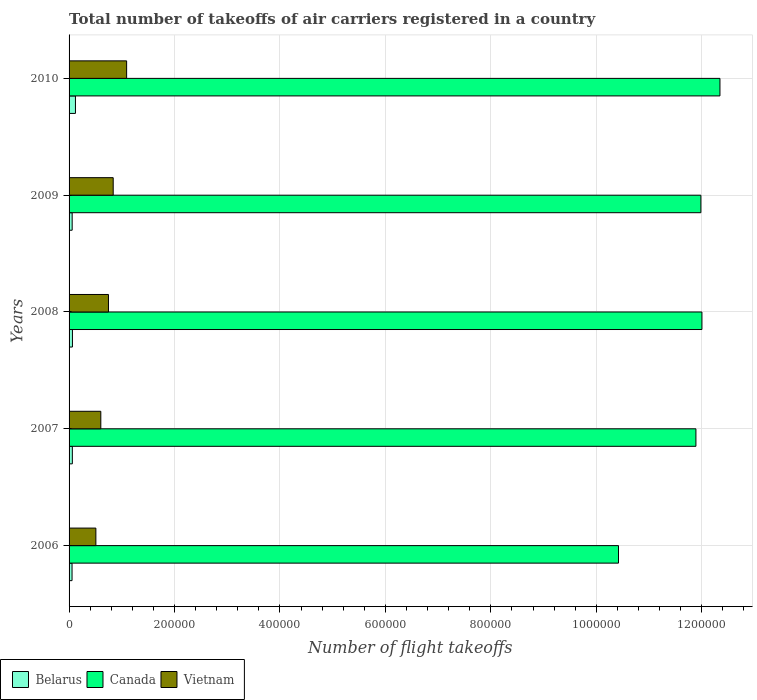How many different coloured bars are there?
Your response must be concise. 3. How many groups of bars are there?
Your answer should be very brief. 5. Are the number of bars per tick equal to the number of legend labels?
Keep it short and to the point. Yes. How many bars are there on the 1st tick from the top?
Your answer should be very brief. 3. What is the label of the 3rd group of bars from the top?
Offer a terse response. 2008. What is the total number of flight takeoffs in Canada in 2006?
Offer a terse response. 1.04e+06. Across all years, what is the maximum total number of flight takeoffs in Vietnam?
Provide a succinct answer. 1.09e+05. Across all years, what is the minimum total number of flight takeoffs in Belarus?
Give a very brief answer. 5646. In which year was the total number of flight takeoffs in Canada maximum?
Provide a short and direct response. 2010. In which year was the total number of flight takeoffs in Belarus minimum?
Give a very brief answer. 2006. What is the total total number of flight takeoffs in Belarus in the graph?
Provide a succinct answer. 3.62e+04. What is the difference between the total number of flight takeoffs in Belarus in 2007 and that in 2010?
Offer a very short reply. -5891. What is the difference between the total number of flight takeoffs in Vietnam in 2010 and the total number of flight takeoffs in Belarus in 2008?
Keep it short and to the point. 1.03e+05. What is the average total number of flight takeoffs in Canada per year?
Provide a succinct answer. 1.17e+06. In the year 2009, what is the difference between the total number of flight takeoffs in Vietnam and total number of flight takeoffs in Belarus?
Provide a succinct answer. 7.79e+04. What is the ratio of the total number of flight takeoffs in Vietnam in 2007 to that in 2008?
Your answer should be compact. 0.81. Is the total number of flight takeoffs in Belarus in 2007 less than that in 2010?
Offer a very short reply. Yes. Is the difference between the total number of flight takeoffs in Vietnam in 2007 and 2008 greater than the difference between the total number of flight takeoffs in Belarus in 2007 and 2008?
Make the answer very short. No. What is the difference between the highest and the second highest total number of flight takeoffs in Canada?
Your answer should be compact. 3.42e+04. What is the difference between the highest and the lowest total number of flight takeoffs in Belarus?
Your response must be concise. 6455. Is the sum of the total number of flight takeoffs in Belarus in 2006 and 2007 greater than the maximum total number of flight takeoffs in Vietnam across all years?
Offer a very short reply. No. What does the 1st bar from the top in 2010 represents?
Your response must be concise. Vietnam. What does the 1st bar from the bottom in 2009 represents?
Offer a terse response. Belarus. Is it the case that in every year, the sum of the total number of flight takeoffs in Belarus and total number of flight takeoffs in Vietnam is greater than the total number of flight takeoffs in Canada?
Give a very brief answer. No. How many years are there in the graph?
Ensure brevity in your answer.  5. Where does the legend appear in the graph?
Give a very brief answer. Bottom left. How are the legend labels stacked?
Give a very brief answer. Horizontal. What is the title of the graph?
Offer a terse response. Total number of takeoffs of air carriers registered in a country. Does "Sint Maarten (Dutch part)" appear as one of the legend labels in the graph?
Ensure brevity in your answer.  No. What is the label or title of the X-axis?
Offer a terse response. Number of flight takeoffs. What is the Number of flight takeoffs of Belarus in 2006?
Keep it short and to the point. 5646. What is the Number of flight takeoffs of Canada in 2006?
Ensure brevity in your answer.  1.04e+06. What is the Number of flight takeoffs of Vietnam in 2006?
Offer a terse response. 5.08e+04. What is the Number of flight takeoffs of Belarus in 2007?
Provide a succinct answer. 6210. What is the Number of flight takeoffs of Canada in 2007?
Give a very brief answer. 1.19e+06. What is the Number of flight takeoffs in Vietnam in 2007?
Offer a very short reply. 6.02e+04. What is the Number of flight takeoffs of Belarus in 2008?
Offer a very short reply. 6371. What is the Number of flight takeoffs of Canada in 2008?
Offer a very short reply. 1.20e+06. What is the Number of flight takeoffs of Vietnam in 2008?
Offer a terse response. 7.47e+04. What is the Number of flight takeoffs in Belarus in 2009?
Keep it short and to the point. 5868. What is the Number of flight takeoffs in Canada in 2009?
Make the answer very short. 1.20e+06. What is the Number of flight takeoffs in Vietnam in 2009?
Keep it short and to the point. 8.37e+04. What is the Number of flight takeoffs in Belarus in 2010?
Ensure brevity in your answer.  1.21e+04. What is the Number of flight takeoffs in Canada in 2010?
Your answer should be compact. 1.23e+06. What is the Number of flight takeoffs of Vietnam in 2010?
Provide a succinct answer. 1.09e+05. Across all years, what is the maximum Number of flight takeoffs of Belarus?
Your answer should be very brief. 1.21e+04. Across all years, what is the maximum Number of flight takeoffs of Canada?
Your response must be concise. 1.23e+06. Across all years, what is the maximum Number of flight takeoffs of Vietnam?
Your answer should be very brief. 1.09e+05. Across all years, what is the minimum Number of flight takeoffs of Belarus?
Your response must be concise. 5646. Across all years, what is the minimum Number of flight takeoffs in Canada?
Keep it short and to the point. 1.04e+06. Across all years, what is the minimum Number of flight takeoffs in Vietnam?
Your answer should be compact. 5.08e+04. What is the total Number of flight takeoffs of Belarus in the graph?
Keep it short and to the point. 3.62e+04. What is the total Number of flight takeoffs of Canada in the graph?
Provide a short and direct response. 5.86e+06. What is the total Number of flight takeoffs in Vietnam in the graph?
Provide a short and direct response. 3.79e+05. What is the difference between the Number of flight takeoffs of Belarus in 2006 and that in 2007?
Your answer should be compact. -564. What is the difference between the Number of flight takeoffs in Canada in 2006 and that in 2007?
Your answer should be compact. -1.47e+05. What is the difference between the Number of flight takeoffs in Vietnam in 2006 and that in 2007?
Make the answer very short. -9378. What is the difference between the Number of flight takeoffs in Belarus in 2006 and that in 2008?
Offer a very short reply. -725. What is the difference between the Number of flight takeoffs of Canada in 2006 and that in 2008?
Provide a succinct answer. -1.58e+05. What is the difference between the Number of flight takeoffs of Vietnam in 2006 and that in 2008?
Ensure brevity in your answer.  -2.39e+04. What is the difference between the Number of flight takeoffs in Belarus in 2006 and that in 2009?
Provide a short and direct response. -222. What is the difference between the Number of flight takeoffs in Canada in 2006 and that in 2009?
Your answer should be very brief. -1.56e+05. What is the difference between the Number of flight takeoffs in Vietnam in 2006 and that in 2009?
Your response must be concise. -3.29e+04. What is the difference between the Number of flight takeoffs in Belarus in 2006 and that in 2010?
Offer a very short reply. -6455. What is the difference between the Number of flight takeoffs in Canada in 2006 and that in 2010?
Your answer should be compact. -1.92e+05. What is the difference between the Number of flight takeoffs in Vietnam in 2006 and that in 2010?
Provide a short and direct response. -5.83e+04. What is the difference between the Number of flight takeoffs in Belarus in 2007 and that in 2008?
Provide a short and direct response. -161. What is the difference between the Number of flight takeoffs of Canada in 2007 and that in 2008?
Provide a succinct answer. -1.14e+04. What is the difference between the Number of flight takeoffs of Vietnam in 2007 and that in 2008?
Provide a short and direct response. -1.45e+04. What is the difference between the Number of flight takeoffs in Belarus in 2007 and that in 2009?
Offer a very short reply. 342. What is the difference between the Number of flight takeoffs in Canada in 2007 and that in 2009?
Your answer should be very brief. -9434. What is the difference between the Number of flight takeoffs in Vietnam in 2007 and that in 2009?
Make the answer very short. -2.35e+04. What is the difference between the Number of flight takeoffs in Belarus in 2007 and that in 2010?
Ensure brevity in your answer.  -5891. What is the difference between the Number of flight takeoffs of Canada in 2007 and that in 2010?
Give a very brief answer. -4.56e+04. What is the difference between the Number of flight takeoffs in Vietnam in 2007 and that in 2010?
Offer a terse response. -4.90e+04. What is the difference between the Number of flight takeoffs in Belarus in 2008 and that in 2009?
Provide a short and direct response. 503. What is the difference between the Number of flight takeoffs in Canada in 2008 and that in 2009?
Your answer should be compact. 1980. What is the difference between the Number of flight takeoffs of Vietnam in 2008 and that in 2009?
Make the answer very short. -8981. What is the difference between the Number of flight takeoffs in Belarus in 2008 and that in 2010?
Your answer should be compact. -5730. What is the difference between the Number of flight takeoffs in Canada in 2008 and that in 2010?
Give a very brief answer. -3.42e+04. What is the difference between the Number of flight takeoffs in Vietnam in 2008 and that in 2010?
Give a very brief answer. -3.44e+04. What is the difference between the Number of flight takeoffs in Belarus in 2009 and that in 2010?
Keep it short and to the point. -6233. What is the difference between the Number of flight takeoffs in Canada in 2009 and that in 2010?
Ensure brevity in your answer.  -3.61e+04. What is the difference between the Number of flight takeoffs of Vietnam in 2009 and that in 2010?
Provide a succinct answer. -2.55e+04. What is the difference between the Number of flight takeoffs of Belarus in 2006 and the Number of flight takeoffs of Canada in 2007?
Keep it short and to the point. -1.18e+06. What is the difference between the Number of flight takeoffs in Belarus in 2006 and the Number of flight takeoffs in Vietnam in 2007?
Provide a short and direct response. -5.46e+04. What is the difference between the Number of flight takeoffs in Canada in 2006 and the Number of flight takeoffs in Vietnam in 2007?
Ensure brevity in your answer.  9.82e+05. What is the difference between the Number of flight takeoffs in Belarus in 2006 and the Number of flight takeoffs in Canada in 2008?
Offer a very short reply. -1.19e+06. What is the difference between the Number of flight takeoffs of Belarus in 2006 and the Number of flight takeoffs of Vietnam in 2008?
Provide a short and direct response. -6.91e+04. What is the difference between the Number of flight takeoffs of Canada in 2006 and the Number of flight takeoffs of Vietnam in 2008?
Provide a short and direct response. 9.67e+05. What is the difference between the Number of flight takeoffs in Belarus in 2006 and the Number of flight takeoffs in Canada in 2009?
Make the answer very short. -1.19e+06. What is the difference between the Number of flight takeoffs of Belarus in 2006 and the Number of flight takeoffs of Vietnam in 2009?
Offer a terse response. -7.81e+04. What is the difference between the Number of flight takeoffs in Canada in 2006 and the Number of flight takeoffs in Vietnam in 2009?
Make the answer very short. 9.58e+05. What is the difference between the Number of flight takeoffs of Belarus in 2006 and the Number of flight takeoffs of Canada in 2010?
Your response must be concise. -1.23e+06. What is the difference between the Number of flight takeoffs of Belarus in 2006 and the Number of flight takeoffs of Vietnam in 2010?
Your response must be concise. -1.04e+05. What is the difference between the Number of flight takeoffs of Canada in 2006 and the Number of flight takeoffs of Vietnam in 2010?
Your answer should be compact. 9.33e+05. What is the difference between the Number of flight takeoffs in Belarus in 2007 and the Number of flight takeoffs in Canada in 2008?
Provide a succinct answer. -1.19e+06. What is the difference between the Number of flight takeoffs of Belarus in 2007 and the Number of flight takeoffs of Vietnam in 2008?
Ensure brevity in your answer.  -6.85e+04. What is the difference between the Number of flight takeoffs in Canada in 2007 and the Number of flight takeoffs in Vietnam in 2008?
Keep it short and to the point. 1.11e+06. What is the difference between the Number of flight takeoffs of Belarus in 2007 and the Number of flight takeoffs of Canada in 2009?
Your answer should be very brief. -1.19e+06. What is the difference between the Number of flight takeoffs of Belarus in 2007 and the Number of flight takeoffs of Vietnam in 2009?
Your response must be concise. -7.75e+04. What is the difference between the Number of flight takeoffs in Canada in 2007 and the Number of flight takeoffs in Vietnam in 2009?
Provide a succinct answer. 1.11e+06. What is the difference between the Number of flight takeoffs in Belarus in 2007 and the Number of flight takeoffs in Canada in 2010?
Provide a short and direct response. -1.23e+06. What is the difference between the Number of flight takeoffs in Belarus in 2007 and the Number of flight takeoffs in Vietnam in 2010?
Offer a terse response. -1.03e+05. What is the difference between the Number of flight takeoffs in Canada in 2007 and the Number of flight takeoffs in Vietnam in 2010?
Offer a terse response. 1.08e+06. What is the difference between the Number of flight takeoffs in Belarus in 2008 and the Number of flight takeoffs in Canada in 2009?
Provide a succinct answer. -1.19e+06. What is the difference between the Number of flight takeoffs of Belarus in 2008 and the Number of flight takeoffs of Vietnam in 2009?
Provide a succinct answer. -7.73e+04. What is the difference between the Number of flight takeoffs in Canada in 2008 and the Number of flight takeoffs in Vietnam in 2009?
Your answer should be compact. 1.12e+06. What is the difference between the Number of flight takeoffs in Belarus in 2008 and the Number of flight takeoffs in Canada in 2010?
Offer a terse response. -1.23e+06. What is the difference between the Number of flight takeoffs in Belarus in 2008 and the Number of flight takeoffs in Vietnam in 2010?
Give a very brief answer. -1.03e+05. What is the difference between the Number of flight takeoffs in Canada in 2008 and the Number of flight takeoffs in Vietnam in 2010?
Offer a terse response. 1.09e+06. What is the difference between the Number of flight takeoffs in Belarus in 2009 and the Number of flight takeoffs in Canada in 2010?
Offer a terse response. -1.23e+06. What is the difference between the Number of flight takeoffs of Belarus in 2009 and the Number of flight takeoffs of Vietnam in 2010?
Provide a short and direct response. -1.03e+05. What is the difference between the Number of flight takeoffs in Canada in 2009 and the Number of flight takeoffs in Vietnam in 2010?
Provide a succinct answer. 1.09e+06. What is the average Number of flight takeoffs of Belarus per year?
Your answer should be compact. 7239.2. What is the average Number of flight takeoffs of Canada per year?
Provide a succinct answer. 1.17e+06. What is the average Number of flight takeoffs of Vietnam per year?
Offer a very short reply. 7.57e+04. In the year 2006, what is the difference between the Number of flight takeoffs of Belarus and Number of flight takeoffs of Canada?
Your answer should be very brief. -1.04e+06. In the year 2006, what is the difference between the Number of flight takeoffs in Belarus and Number of flight takeoffs in Vietnam?
Keep it short and to the point. -4.52e+04. In the year 2006, what is the difference between the Number of flight takeoffs in Canada and Number of flight takeoffs in Vietnam?
Your answer should be compact. 9.91e+05. In the year 2007, what is the difference between the Number of flight takeoffs in Belarus and Number of flight takeoffs in Canada?
Provide a succinct answer. -1.18e+06. In the year 2007, what is the difference between the Number of flight takeoffs of Belarus and Number of flight takeoffs of Vietnam?
Keep it short and to the point. -5.40e+04. In the year 2007, what is the difference between the Number of flight takeoffs in Canada and Number of flight takeoffs in Vietnam?
Your response must be concise. 1.13e+06. In the year 2008, what is the difference between the Number of flight takeoffs of Belarus and Number of flight takeoffs of Canada?
Your answer should be very brief. -1.19e+06. In the year 2008, what is the difference between the Number of flight takeoffs in Belarus and Number of flight takeoffs in Vietnam?
Keep it short and to the point. -6.84e+04. In the year 2008, what is the difference between the Number of flight takeoffs in Canada and Number of flight takeoffs in Vietnam?
Give a very brief answer. 1.13e+06. In the year 2009, what is the difference between the Number of flight takeoffs of Belarus and Number of flight takeoffs of Canada?
Make the answer very short. -1.19e+06. In the year 2009, what is the difference between the Number of flight takeoffs in Belarus and Number of flight takeoffs in Vietnam?
Your response must be concise. -7.79e+04. In the year 2009, what is the difference between the Number of flight takeoffs in Canada and Number of flight takeoffs in Vietnam?
Offer a very short reply. 1.11e+06. In the year 2010, what is the difference between the Number of flight takeoffs in Belarus and Number of flight takeoffs in Canada?
Your answer should be very brief. -1.22e+06. In the year 2010, what is the difference between the Number of flight takeoffs of Belarus and Number of flight takeoffs of Vietnam?
Offer a terse response. -9.71e+04. In the year 2010, what is the difference between the Number of flight takeoffs in Canada and Number of flight takeoffs in Vietnam?
Ensure brevity in your answer.  1.13e+06. What is the ratio of the Number of flight takeoffs in Belarus in 2006 to that in 2007?
Give a very brief answer. 0.91. What is the ratio of the Number of flight takeoffs in Canada in 2006 to that in 2007?
Provide a short and direct response. 0.88. What is the ratio of the Number of flight takeoffs in Vietnam in 2006 to that in 2007?
Give a very brief answer. 0.84. What is the ratio of the Number of flight takeoffs of Belarus in 2006 to that in 2008?
Your answer should be compact. 0.89. What is the ratio of the Number of flight takeoffs of Canada in 2006 to that in 2008?
Provide a succinct answer. 0.87. What is the ratio of the Number of flight takeoffs of Vietnam in 2006 to that in 2008?
Your answer should be very brief. 0.68. What is the ratio of the Number of flight takeoffs in Belarus in 2006 to that in 2009?
Keep it short and to the point. 0.96. What is the ratio of the Number of flight takeoffs of Canada in 2006 to that in 2009?
Provide a succinct answer. 0.87. What is the ratio of the Number of flight takeoffs in Vietnam in 2006 to that in 2009?
Ensure brevity in your answer.  0.61. What is the ratio of the Number of flight takeoffs in Belarus in 2006 to that in 2010?
Your response must be concise. 0.47. What is the ratio of the Number of flight takeoffs of Canada in 2006 to that in 2010?
Provide a short and direct response. 0.84. What is the ratio of the Number of flight takeoffs of Vietnam in 2006 to that in 2010?
Give a very brief answer. 0.47. What is the ratio of the Number of flight takeoffs of Belarus in 2007 to that in 2008?
Offer a terse response. 0.97. What is the ratio of the Number of flight takeoffs in Canada in 2007 to that in 2008?
Offer a very short reply. 0.99. What is the ratio of the Number of flight takeoffs of Vietnam in 2007 to that in 2008?
Ensure brevity in your answer.  0.81. What is the ratio of the Number of flight takeoffs in Belarus in 2007 to that in 2009?
Ensure brevity in your answer.  1.06. What is the ratio of the Number of flight takeoffs of Canada in 2007 to that in 2009?
Your response must be concise. 0.99. What is the ratio of the Number of flight takeoffs of Vietnam in 2007 to that in 2009?
Provide a succinct answer. 0.72. What is the ratio of the Number of flight takeoffs of Belarus in 2007 to that in 2010?
Your response must be concise. 0.51. What is the ratio of the Number of flight takeoffs of Canada in 2007 to that in 2010?
Give a very brief answer. 0.96. What is the ratio of the Number of flight takeoffs in Vietnam in 2007 to that in 2010?
Keep it short and to the point. 0.55. What is the ratio of the Number of flight takeoffs of Belarus in 2008 to that in 2009?
Ensure brevity in your answer.  1.09. What is the ratio of the Number of flight takeoffs of Vietnam in 2008 to that in 2009?
Offer a terse response. 0.89. What is the ratio of the Number of flight takeoffs of Belarus in 2008 to that in 2010?
Make the answer very short. 0.53. What is the ratio of the Number of flight takeoffs in Canada in 2008 to that in 2010?
Your answer should be very brief. 0.97. What is the ratio of the Number of flight takeoffs in Vietnam in 2008 to that in 2010?
Your answer should be compact. 0.68. What is the ratio of the Number of flight takeoffs of Belarus in 2009 to that in 2010?
Keep it short and to the point. 0.48. What is the ratio of the Number of flight takeoffs of Canada in 2009 to that in 2010?
Offer a very short reply. 0.97. What is the ratio of the Number of flight takeoffs of Vietnam in 2009 to that in 2010?
Make the answer very short. 0.77. What is the difference between the highest and the second highest Number of flight takeoffs of Belarus?
Provide a succinct answer. 5730. What is the difference between the highest and the second highest Number of flight takeoffs of Canada?
Provide a succinct answer. 3.42e+04. What is the difference between the highest and the second highest Number of flight takeoffs of Vietnam?
Your response must be concise. 2.55e+04. What is the difference between the highest and the lowest Number of flight takeoffs in Belarus?
Offer a very short reply. 6455. What is the difference between the highest and the lowest Number of flight takeoffs in Canada?
Your answer should be very brief. 1.92e+05. What is the difference between the highest and the lowest Number of flight takeoffs of Vietnam?
Provide a short and direct response. 5.83e+04. 